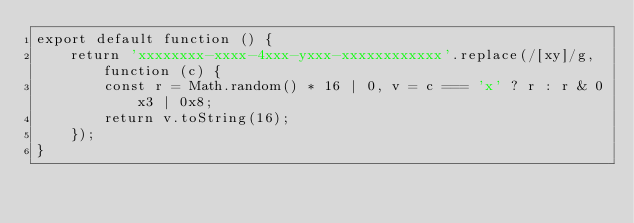<code> <loc_0><loc_0><loc_500><loc_500><_TypeScript_>export default function () {
    return 'xxxxxxxx-xxxx-4xxx-yxxx-xxxxxxxxxxxx'.replace(/[xy]/g, function (c) {
        const r = Math.random() * 16 | 0, v = c === 'x' ? r : r & 0x3 | 0x8;
        return v.toString(16);
    });
}</code> 